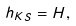<formula> <loc_0><loc_0><loc_500><loc_500>h _ { K S } = H ,</formula> 